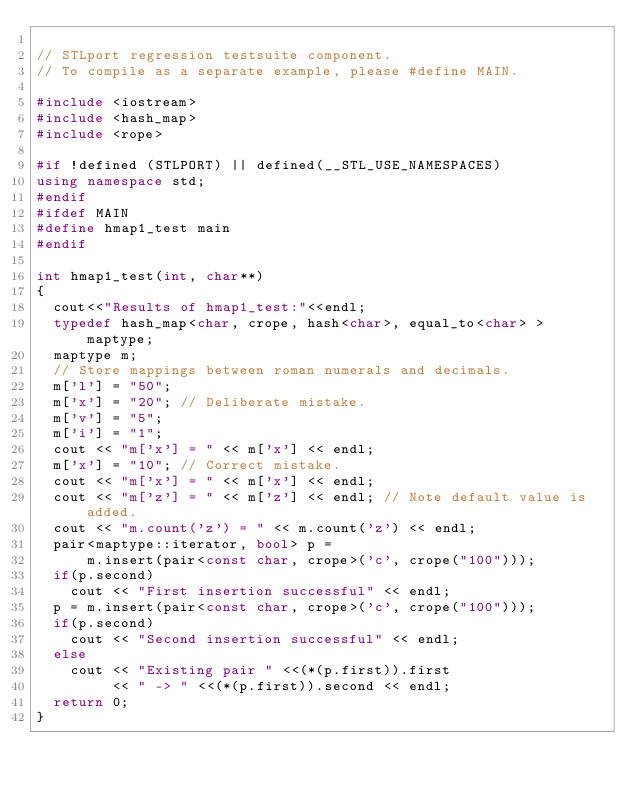<code> <loc_0><loc_0><loc_500><loc_500><_C++_>
// STLport regression testsuite component.
// To compile as a separate example, please #define MAIN.

#include <iostream>
#include <hash_map>
#include <rope>

#if !defined (STLPORT) || defined(__STL_USE_NAMESPACES)
using namespace std;
#endif
#ifdef MAIN 
#define hmap1_test main
#endif

int hmap1_test(int, char**)
{
  cout<<"Results of hmap1_test:"<<endl;
  typedef hash_map<char, crope, hash<char>, equal_to<char> > maptype;
  maptype m;
  // Store mappings between roman numerals and decimals.
  m['l'] = "50";
  m['x'] = "20"; // Deliberate mistake.
  m['v'] = "5";
  m['i'] = "1";
  cout << "m['x'] = " << m['x'] << endl;
  m['x'] = "10"; // Correct mistake.
  cout << "m['x'] = " << m['x'] << endl;
  cout << "m['z'] = " << m['z'] << endl; // Note default value is added.
  cout << "m.count('z') = " << m.count('z') << endl;
  pair<maptype::iterator, bool> p =
      m.insert(pair<const char, crope>('c', crope("100")));
  if(p.second)
    cout << "First insertion successful" << endl;
  p = m.insert(pair<const char, crope>('c', crope("100")));
  if(p.second)
    cout << "Second insertion successful" << endl;
  else
    cout << "Existing pair " <<(*(p.first)).first
         << " -> " <<(*(p.first)).second << endl;
  return 0;
}
</code> 